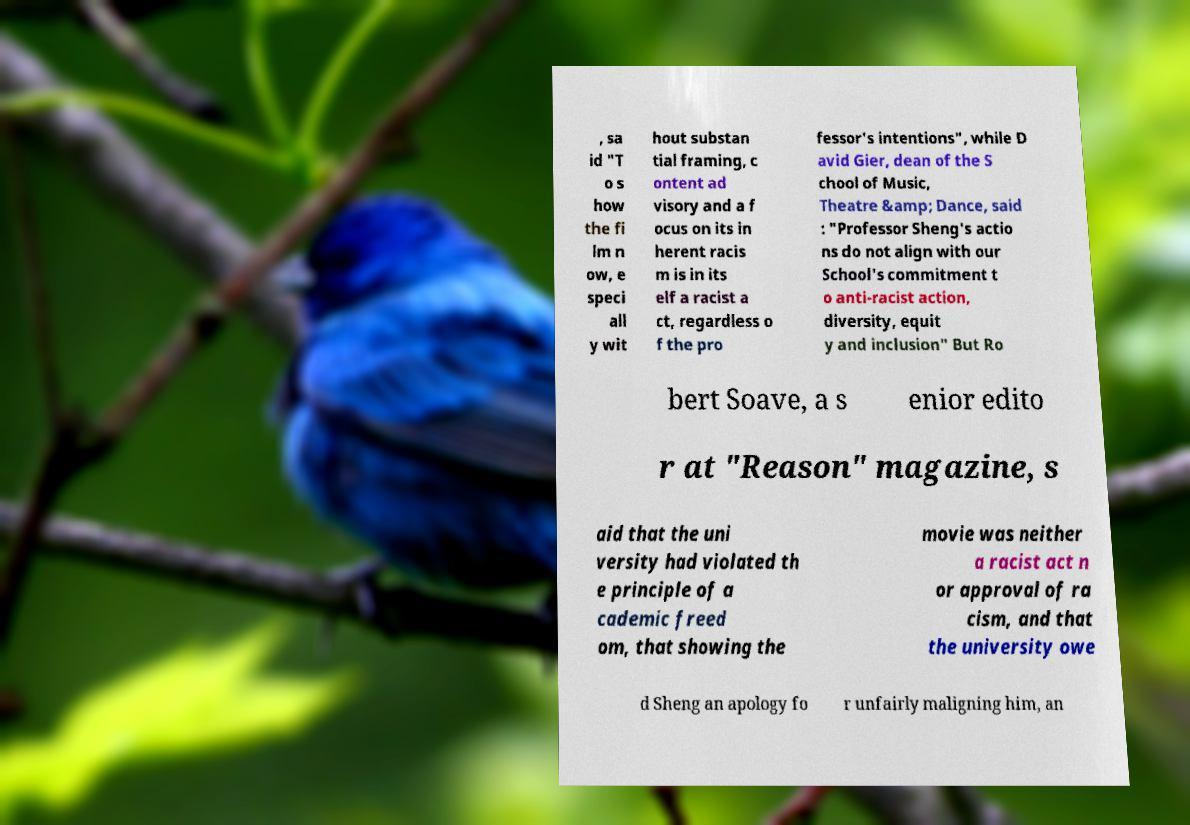For documentation purposes, I need the text within this image transcribed. Could you provide that? , sa id "T o s how the fi lm n ow, e speci all y wit hout substan tial framing, c ontent ad visory and a f ocus on its in herent racis m is in its elf a racist a ct, regardless o f the pro fessor's intentions", while D avid Gier, dean of the S chool of Music, Theatre &amp; Dance, said : "Professor Sheng's actio ns do not align with our School's commitment t o anti-racist action, diversity, equit y and inclusion" But Ro bert Soave, a s enior edito r at "Reason" magazine, s aid that the uni versity had violated th e principle of a cademic freed om, that showing the movie was neither a racist act n or approval of ra cism, and that the university owe d Sheng an apology fo r unfairly maligning him, an 